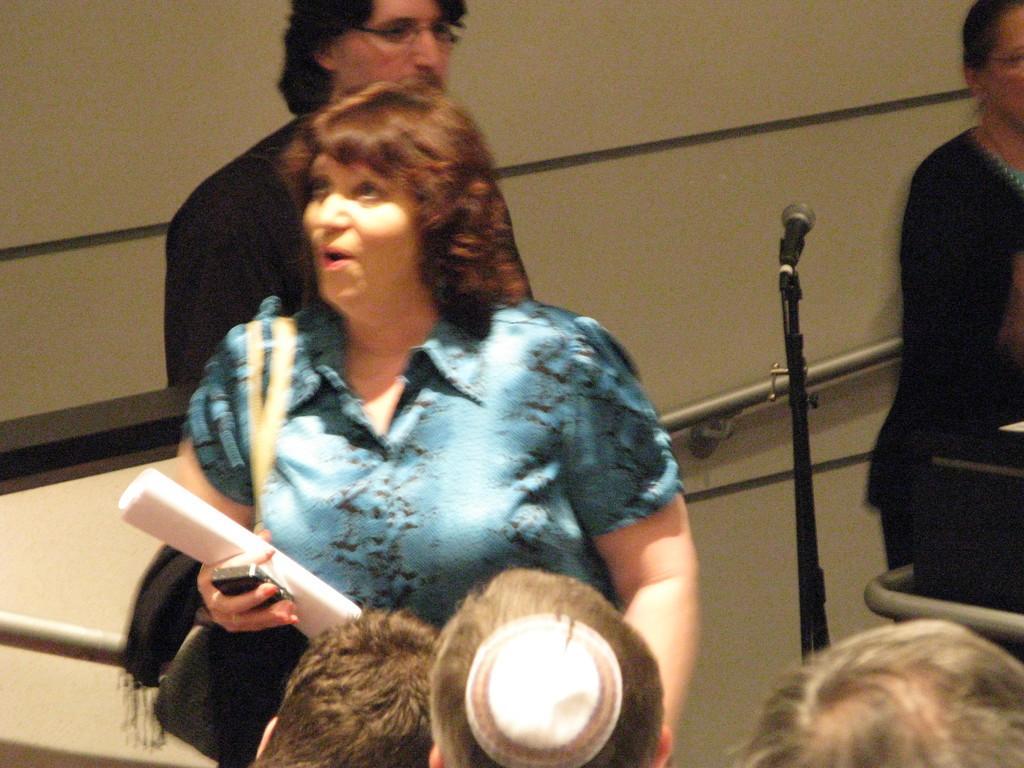Describe this image in one or two sentences. In this image in the center there is one woman who is holding papers, mobile and wearing a bag. And at the bottom there are three peoples heads are visible, and in the background there is a mike and some poles and wall and there are two people standing and some other objects. 